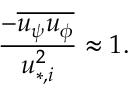Convert formula to latex. <formula><loc_0><loc_0><loc_500><loc_500>\frac { - \overline { { u _ { \psi } u _ { \phi } } } } { u _ { * , i } ^ { 2 } } \approx 1 .</formula> 